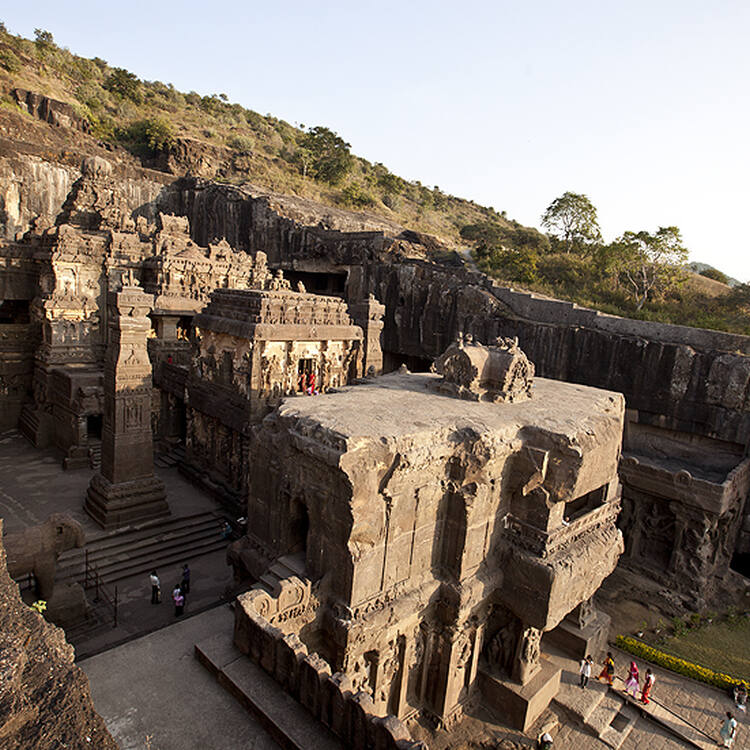What is the unique architectural feature of the Ellora Caves? A unique architectural feature of the Ellora Caves is the extensive use of rock-cut architecture to create elaborate temple complexes. Unlike conventional construction, these structures are carved directly into the mountain rock, and in some cases, like Cave 16 (the Kailasa temple), entirely from a single rock formation. This technique allowed for seamless integration of sculptures, pillars, and sanctuaries, showcasing advanced engineering skills and artistic ingenuity. The precision and detail achieved in carving intricate religious motifs and deities reflect the high level of craftsmanship and architectural innovation of ancient India. 